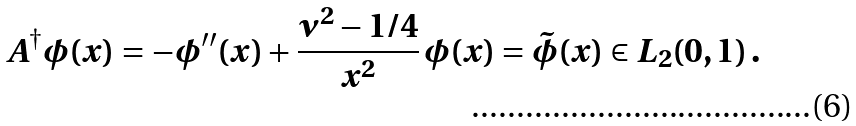Convert formula to latex. <formula><loc_0><loc_0><loc_500><loc_500>A ^ { \dagger } \phi ( x ) = - \phi ^ { \prime \prime } ( x ) + \frac { \nu ^ { 2 } - 1 / 4 } { x ^ { 2 } } \, \phi ( x ) = \tilde { \phi } ( x ) \in L _ { 2 } ( 0 , 1 ) \, .</formula> 